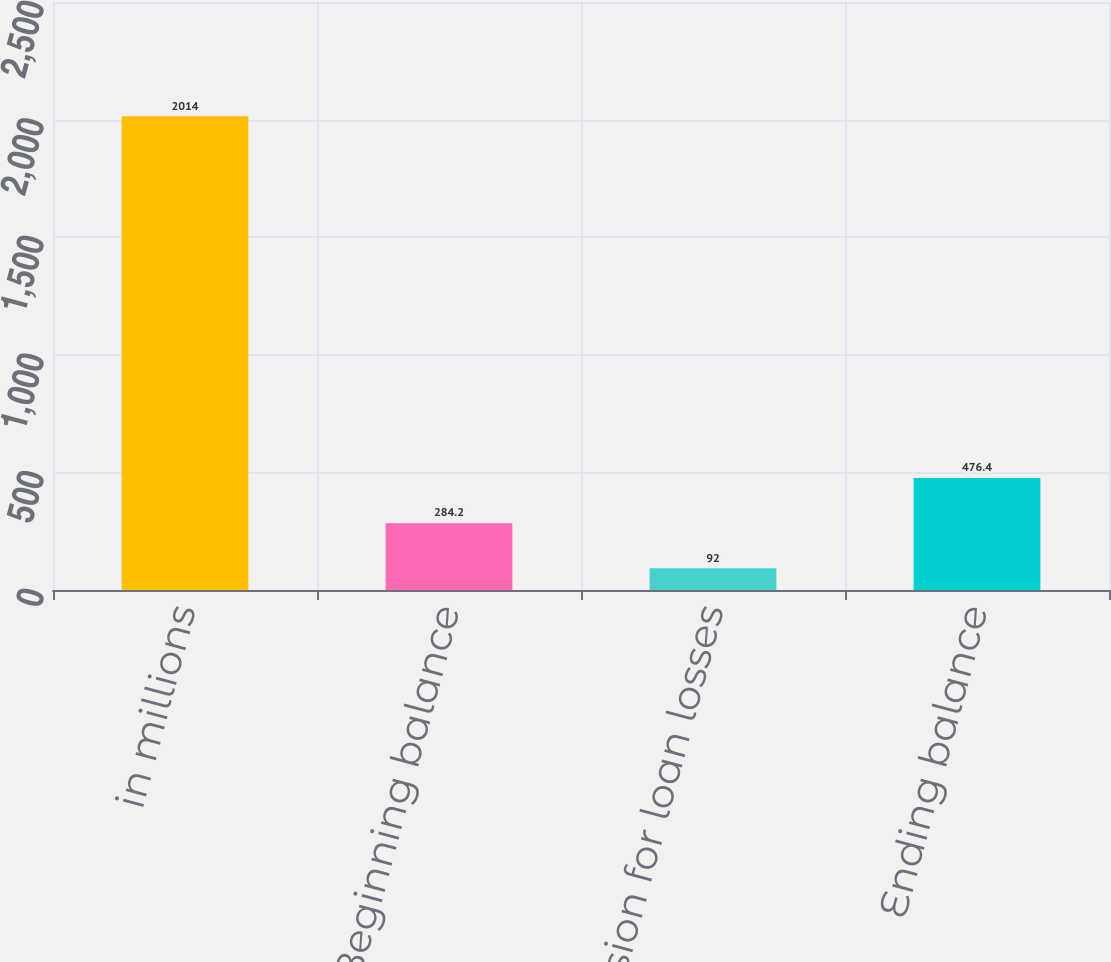Convert chart. <chart><loc_0><loc_0><loc_500><loc_500><bar_chart><fcel>in millions<fcel>Beginning balance<fcel>Provision for loan losses<fcel>Ending balance<nl><fcel>2014<fcel>284.2<fcel>92<fcel>476.4<nl></chart> 